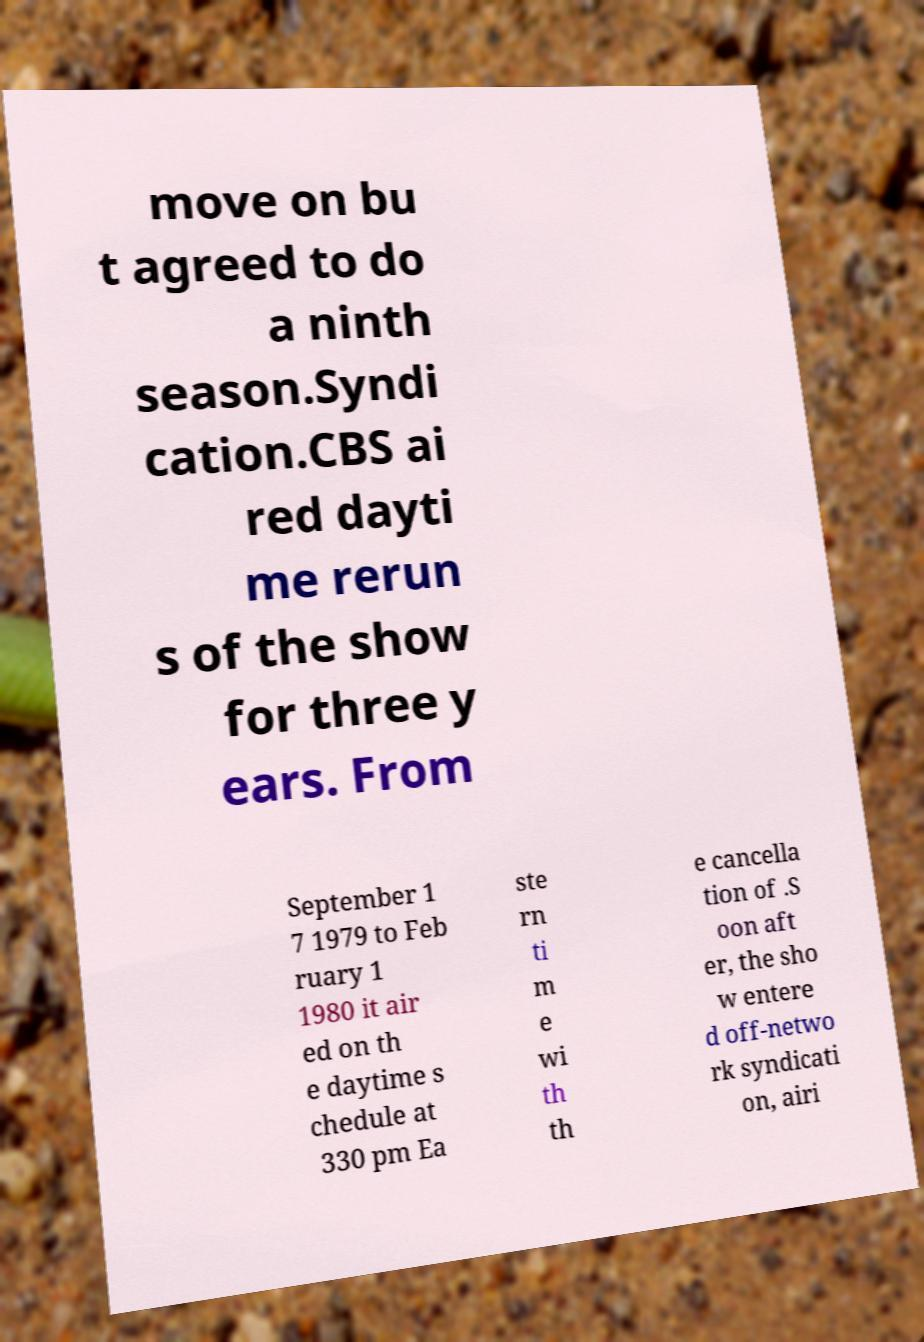Could you assist in decoding the text presented in this image and type it out clearly? move on bu t agreed to do a ninth season.Syndi cation.CBS ai red dayti me rerun s of the show for three y ears. From September 1 7 1979 to Feb ruary 1 1980 it air ed on th e daytime s chedule at 330 pm Ea ste rn ti m e wi th th e cancella tion of .S oon aft er, the sho w entere d off-netwo rk syndicati on, airi 